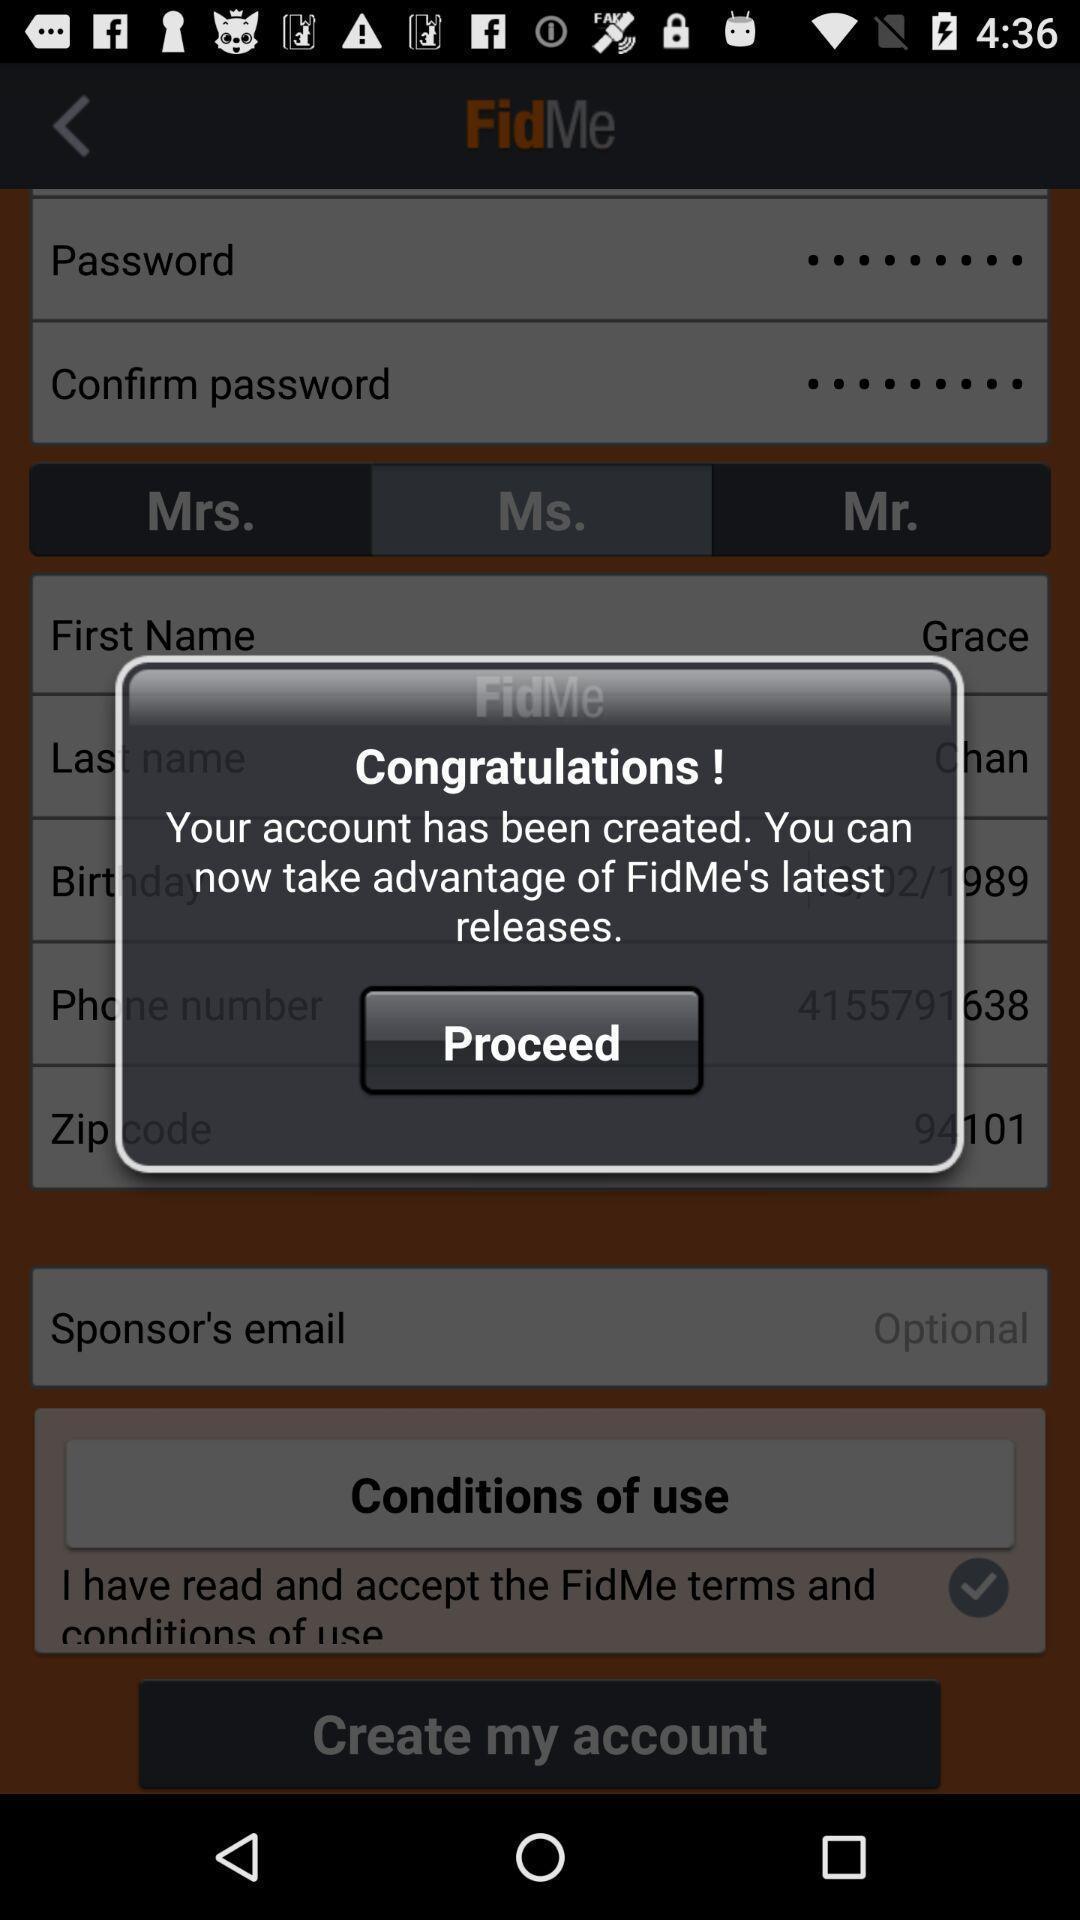What details can you identify in this image? Pop-up shows proceed option for an app. 